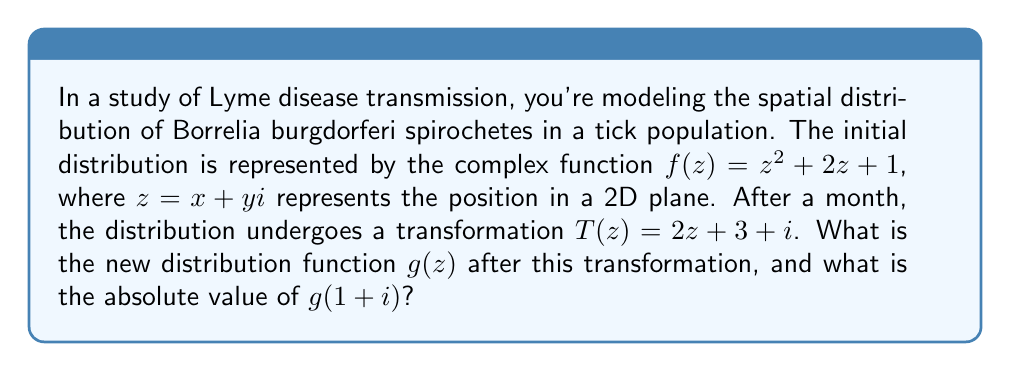Help me with this question. To solve this problem, we'll follow these steps:

1) The initial distribution is given by $f(z) = z^2 + 2z + 1$.

2) The transformation $T(z) = 2z + 3 + i$ is applied to this distribution.

3) To find the new distribution $g(z)$, we need to compose $f$ with the inverse of $T$:
   
   $g(z) = f(T^{-1}(z))$

4) First, let's find $T^{-1}(z)$:
   
   $w = 2z + 3 + i$
   $w - 3 - i = 2z$
   $z = \frac{w - 3 - i}{2}$

   So, $T^{-1}(z) = \frac{z - 3 - i}{2}$

5) Now we can find $g(z)$:

   $g(z) = f(T^{-1}(z)) = (\frac{z - 3 - i}{2})^2 + 2(\frac{z - 3 - i}{2}) + 1$

6) Simplify:
   
   $g(z) = \frac{(z - 3 - i)^2}{4} + \frac{2z - 6 - 2i}{2} + 1$
   
   $= \frac{z^2 - 6z - 2zi + 9 + 6i + i^2}{4} + z - 3 - i + 1$
   
   $= \frac{z^2 - 6z - 2zi + 8 + 6i}{4} + z - 2 - i$
   
   $= \frac{z^2 - 6z - 2zi + 8 + 6i + 4z - 8 - 4i}{4}$
   
   $= \frac{z^2 - 2z - 2zi + 2i}{4}$
   
   $g(z) = \frac{1}{4}z^2 - \frac{1}{2}z - \frac{1}{2}zi + \frac{1}{2}i$

7) To find $|g(1+i)|$, we substitute $z = 1+i$ into $g(z)$:

   $g(1+i) = \frac{1}{4}(1+i)^2 - \frac{1}{2}(1+i) - \frac{1}{2}(1+i)i + \frac{1}{2}i$
   
   $= \frac{1}{4}(1+2i-1) - \frac{1}{2} - \frac{1}{2}i - \frac{1}{2}i + \frac{1}{2}i + \frac{1}{2}i$
   
   $= \frac{1}{2}i - \frac{1}{2} - \frac{1}{2}i$
   
   $= -\frac{1}{2}$

8) The absolute value of a real number is its non-negative value:

   $|g(1+i)| = |-\frac{1}{2}| = \frac{1}{2}$
Answer: $\frac{1}{2}$ 